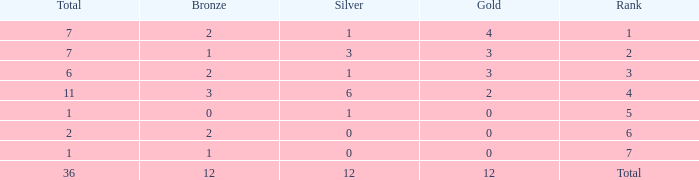What is the largest total for a team with fewer than 12 bronze, 1 silver and 0 gold medals? 1.0. 